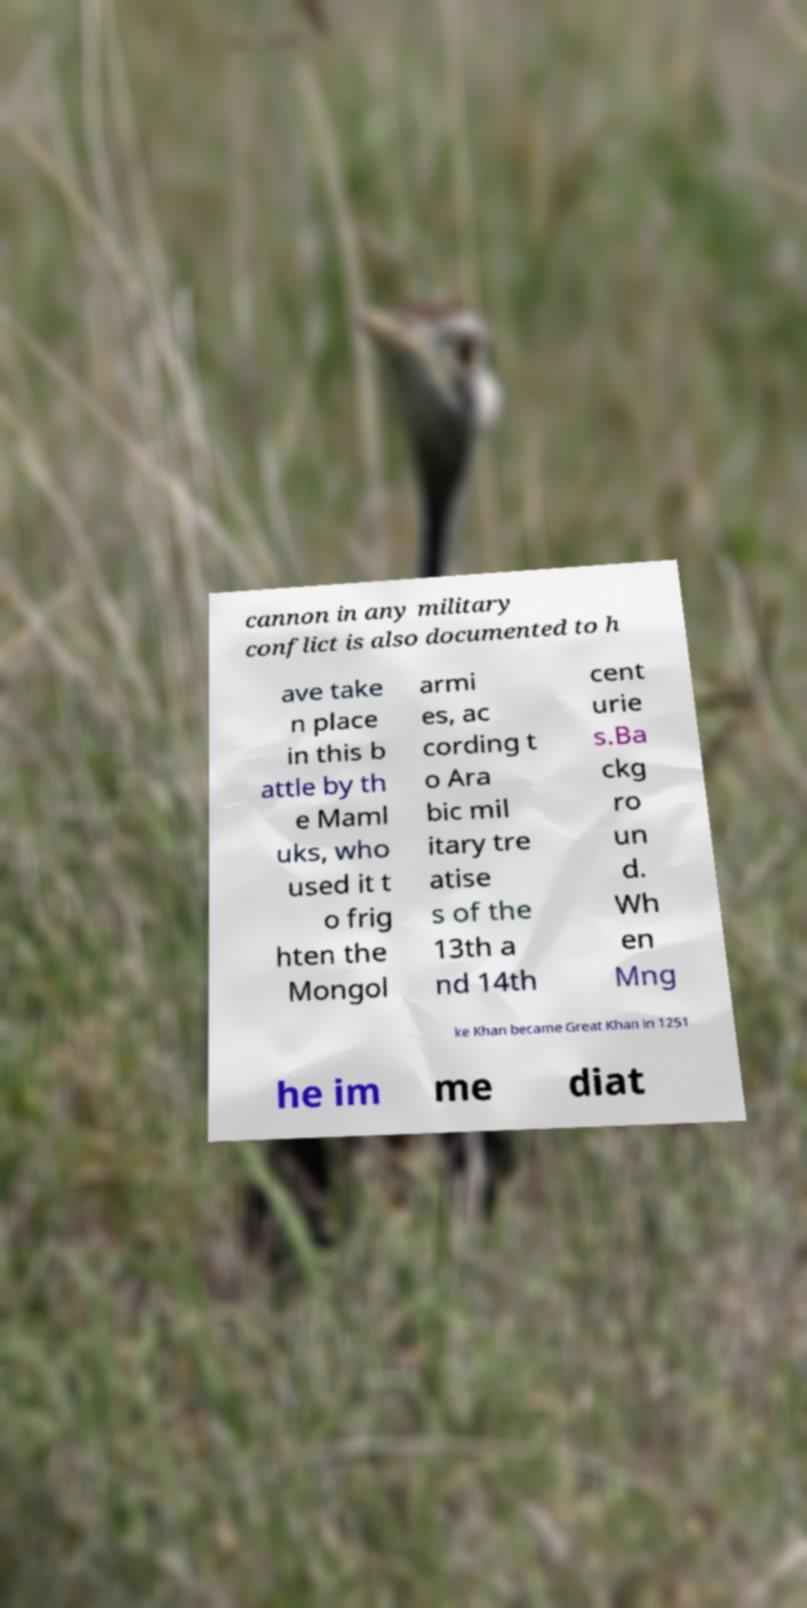Can you accurately transcribe the text from the provided image for me? cannon in any military conflict is also documented to h ave take n place in this b attle by th e Maml uks, who used it t o frig hten the Mongol armi es, ac cording t o Ara bic mil itary tre atise s of the 13th a nd 14th cent urie s.Ba ckg ro un d. Wh en Mng ke Khan became Great Khan in 1251 he im me diat 